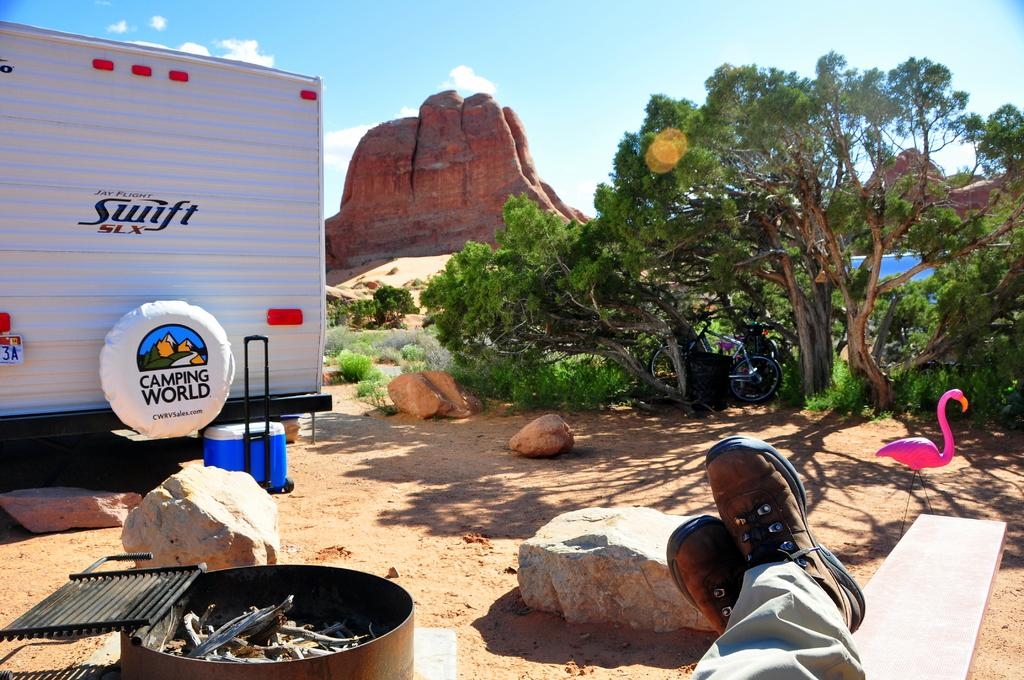What part of a person or object can be seen in the image? There are legs visible in the image. What type of natural objects are present in the image? There are big stones in the image. What is located on the left side of the image? There is a vehicle on the left side of the image. What can be seen in the distance in the image? There are trees in the background of the image. What is visible in the sky in the background of the image? There are clouds in the sky in the background of the image. What type of light can be seen emanating from the vehicle in the image? There is no indication of any light emanating from the vehicle in the image. What message of love is being conveyed by the big stones in the image? There is no message of love present in the image; it simply features big stones. 